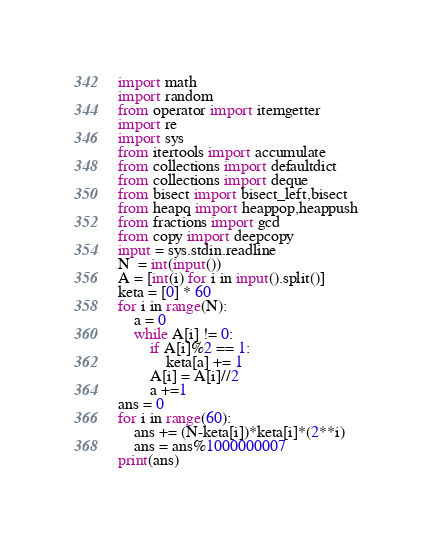Convert code to text. <code><loc_0><loc_0><loc_500><loc_500><_Python_>import math
import random
from operator import itemgetter
import re
import sys
from itertools import accumulate
from collections import defaultdict
from collections import deque
from bisect import bisect_left,bisect
from heapq import heappop,heappush
from fractions import gcd
from copy import deepcopy
input = sys.stdin.readline
N  = int(input())
A = [int(i) for i in input().split()]
keta = [0] * 60
for i in range(N):
    a = 0
    while A[i] != 0:
        if A[i]%2 == 1:
            keta[a] += 1
        A[i] = A[i]//2
        a +=1
ans = 0
for i in range(60):
    ans += (N-keta[i])*keta[i]*(2**i)
    ans = ans%1000000007
print(ans)
</code> 